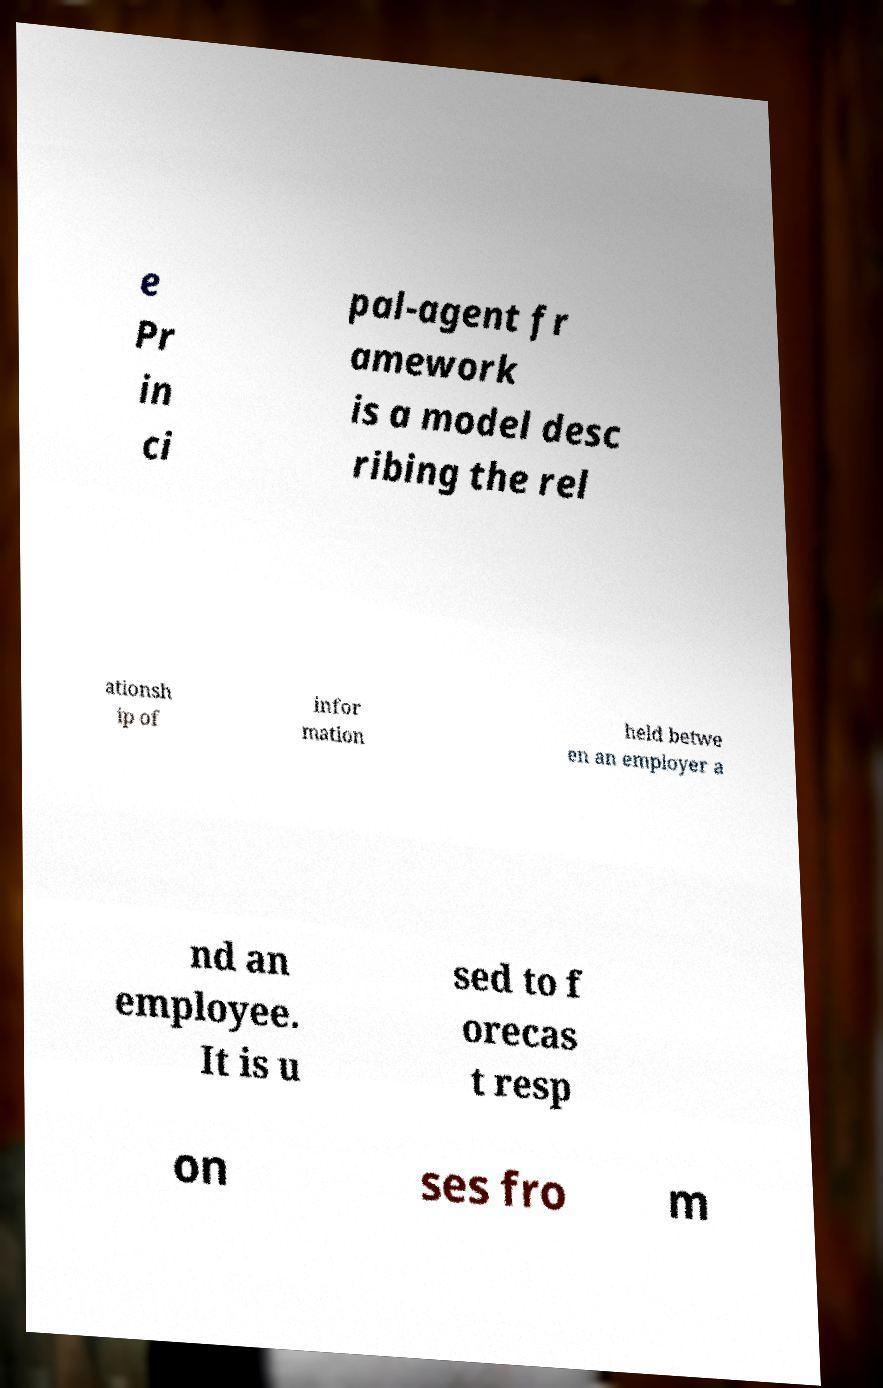Could you extract and type out the text from this image? e Pr in ci pal-agent fr amework is a model desc ribing the rel ationsh ip of infor mation held betwe en an employer a nd an employee. It is u sed to f orecas t resp on ses fro m 